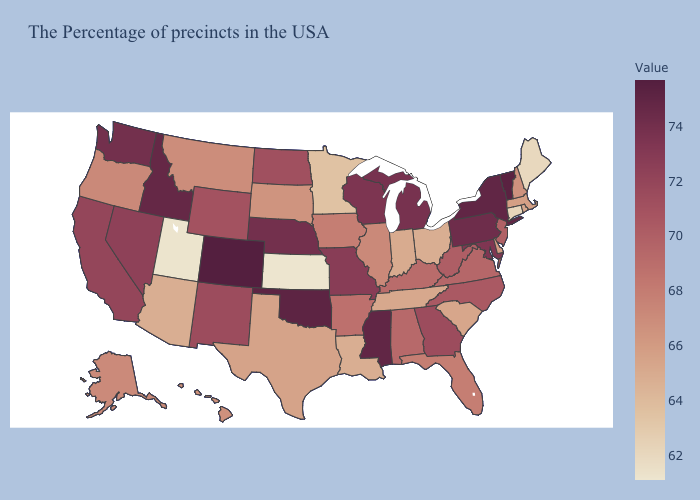Does Tennessee have the lowest value in the USA?
Write a very short answer. No. Does Kansas have the lowest value in the USA?
Be succinct. Yes. Does the map have missing data?
Give a very brief answer. No. Does Michigan have a higher value than Tennessee?
Write a very short answer. Yes. Which states have the lowest value in the Northeast?
Give a very brief answer. Maine. Among the states that border Idaho , does Utah have the lowest value?
Give a very brief answer. Yes. 